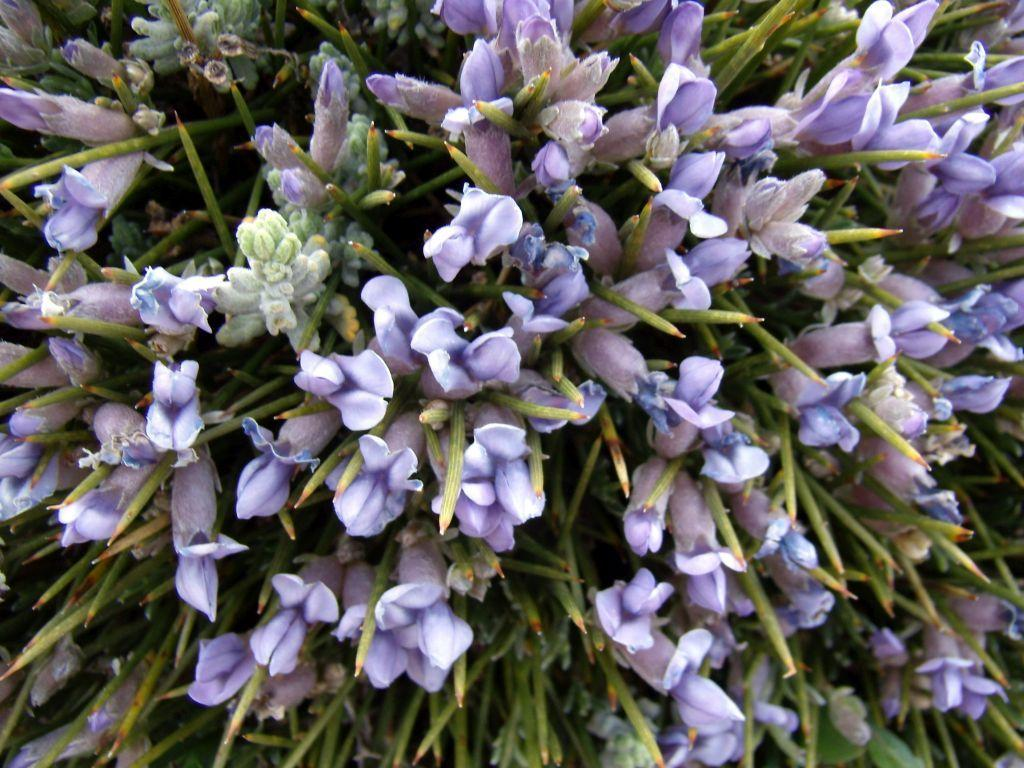What type of living organisms can be seen in the image? Plants can be seen in the image. What specific features can be observed on the plants? The plants have flowers and buds. What color are the flowers and buds? The flowers and buds are in violet color. What is the name of the scent that the plants emit in the image? The image does not provide information about the scent of the plants, so it cannot be determined from the image. 